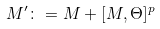Convert formula to latex. <formula><loc_0><loc_0><loc_500><loc_500>M ^ { \prime } \colon = M + [ M , \Theta ] ^ { p }</formula> 